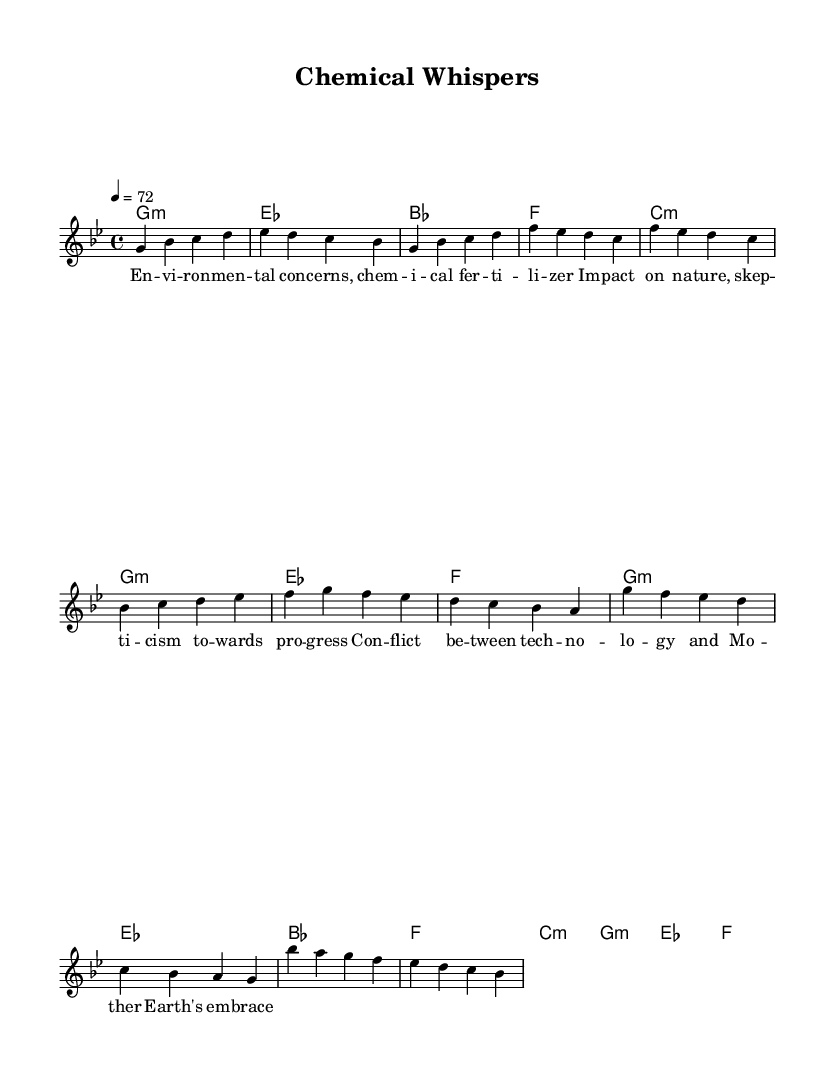What is the key signature of this music? The key signature is G minor, which has two flats (B♭ and E♭).
Answer: G minor What is the time signature in this piece? The time signature shown in the music is 4/4, indicating four beats per measure.
Answer: 4/4 What is the tempo marking for this piece? The tempo marking indicates a speed of 72 beats per minute; this is specified in the score as "4 = 72".
Answer: 72 How many measures are in the verse section? By counting the measures indicated in the verse section of the score, there are four measures total.
Answer: 4 What is the first chord in the verse? The first chord presented in the harmony section for the verse is G minor.
Answer: G minor How does the pre-chorus differ from the verse? The pre-chorus introduces a new chord progression starting with C minor, signifying a shift in harmony from the verse's use of G minor.
Answer: New chord progression What theme does the lyrics reflect in the song? The lyrics reflect concerns regarding environmental impacts associated with chemical fertilizers, expressed through their words.
Answer: Environmental concerns 